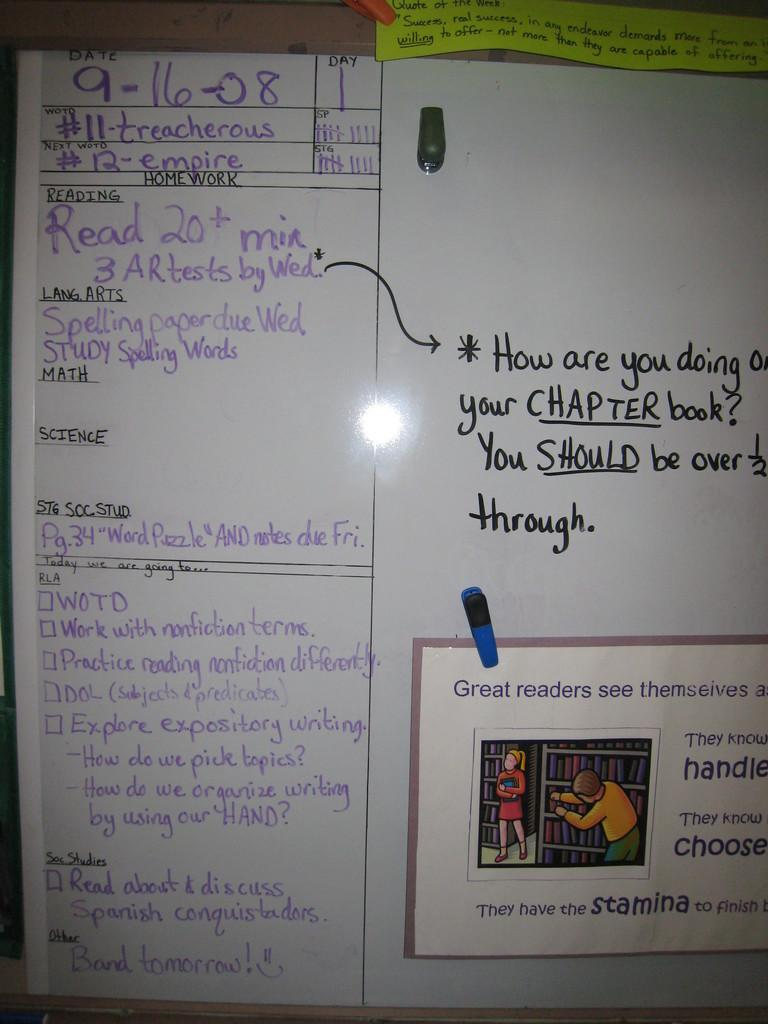<image>
Write a terse but informative summary of the picture. A whiteboard, on which a question beginning 'how are you' is asked. 